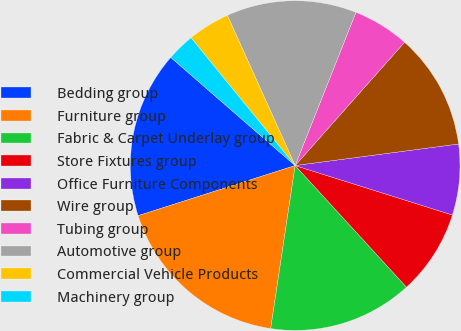Convert chart to OTSL. <chart><loc_0><loc_0><loc_500><loc_500><pie_chart><fcel>Bedding group<fcel>Furniture group<fcel>Fabric & Carpet Underlay group<fcel>Store Fixtures group<fcel>Office Furniture Components<fcel>Wire group<fcel>Tubing group<fcel>Automotive group<fcel>Commercial Vehicle Products<fcel>Machinery group<nl><fcel>16.31%<fcel>17.71%<fcel>14.17%<fcel>8.35%<fcel>6.94%<fcel>11.36%<fcel>5.54%<fcel>12.76%<fcel>4.13%<fcel>2.73%<nl></chart> 